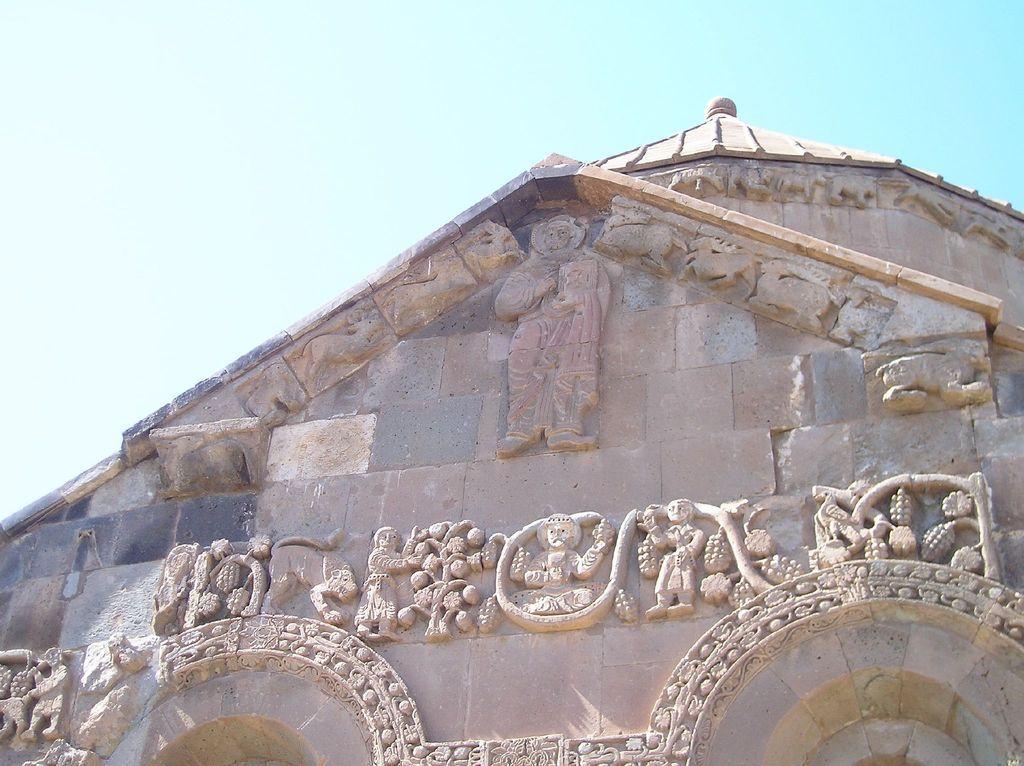Could you give a brief overview of what you see in this image? In this image I can see a part of a building. There are some sculptures on the wall. At the top of the image I can see the sky. 